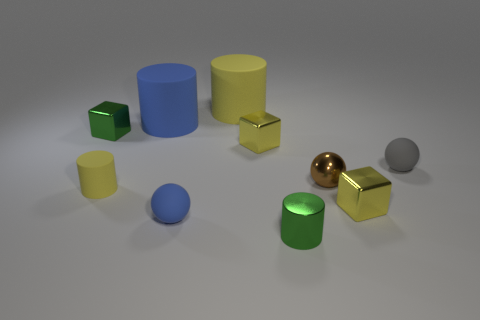What can you tell me about the lighting in this image? The image has soft, diffused lighting coming from above, casting gentle shadows beneath each object and giving the scene a calm and even appearance. Is there any reflection on the objects that indicates the surface they are on? Yes, there are subtle reflections visible beneath the objects, especially the metallic ones, indicating that they are resting on a smooth, possibly glossy surface. 